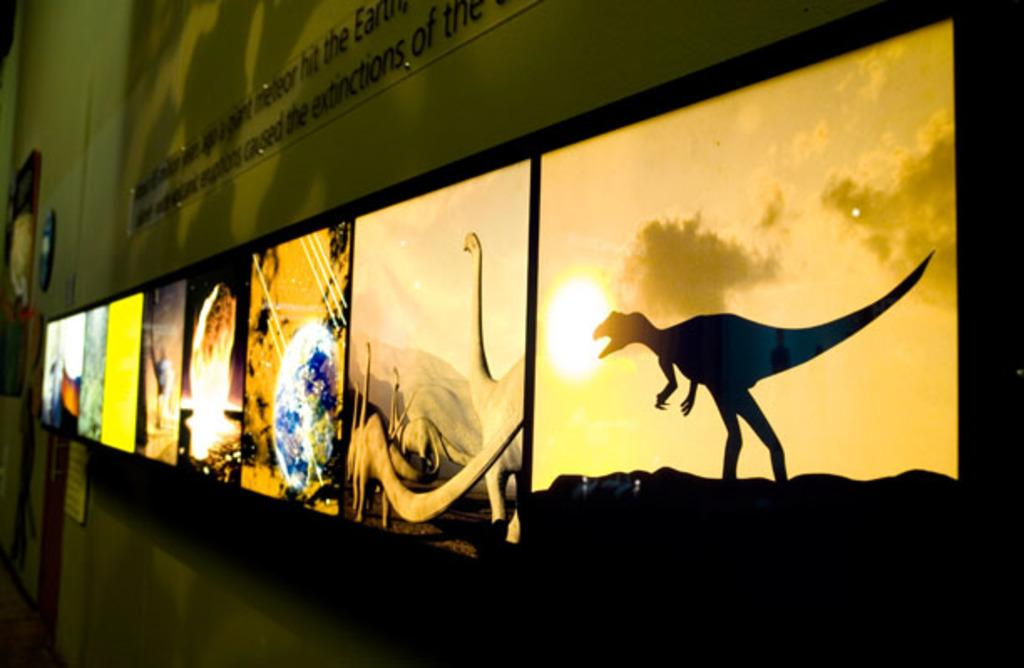What objects are attached to the wall in the image? There are frames and a glass board attached to the wall in the image. What is the purpose of the glass board in the image? The purpose of the glass board is not specified, but it is likely used for writing or displaying information. How are the frames and the glass board attached to the wall? Both the frames and the glass board are attached to the wall, but the specific method of attachment is not mentioned. What activity is taking place in the image involving a drawer? There is no drawer present in the image, so no activity involving a drawer can be observed. 